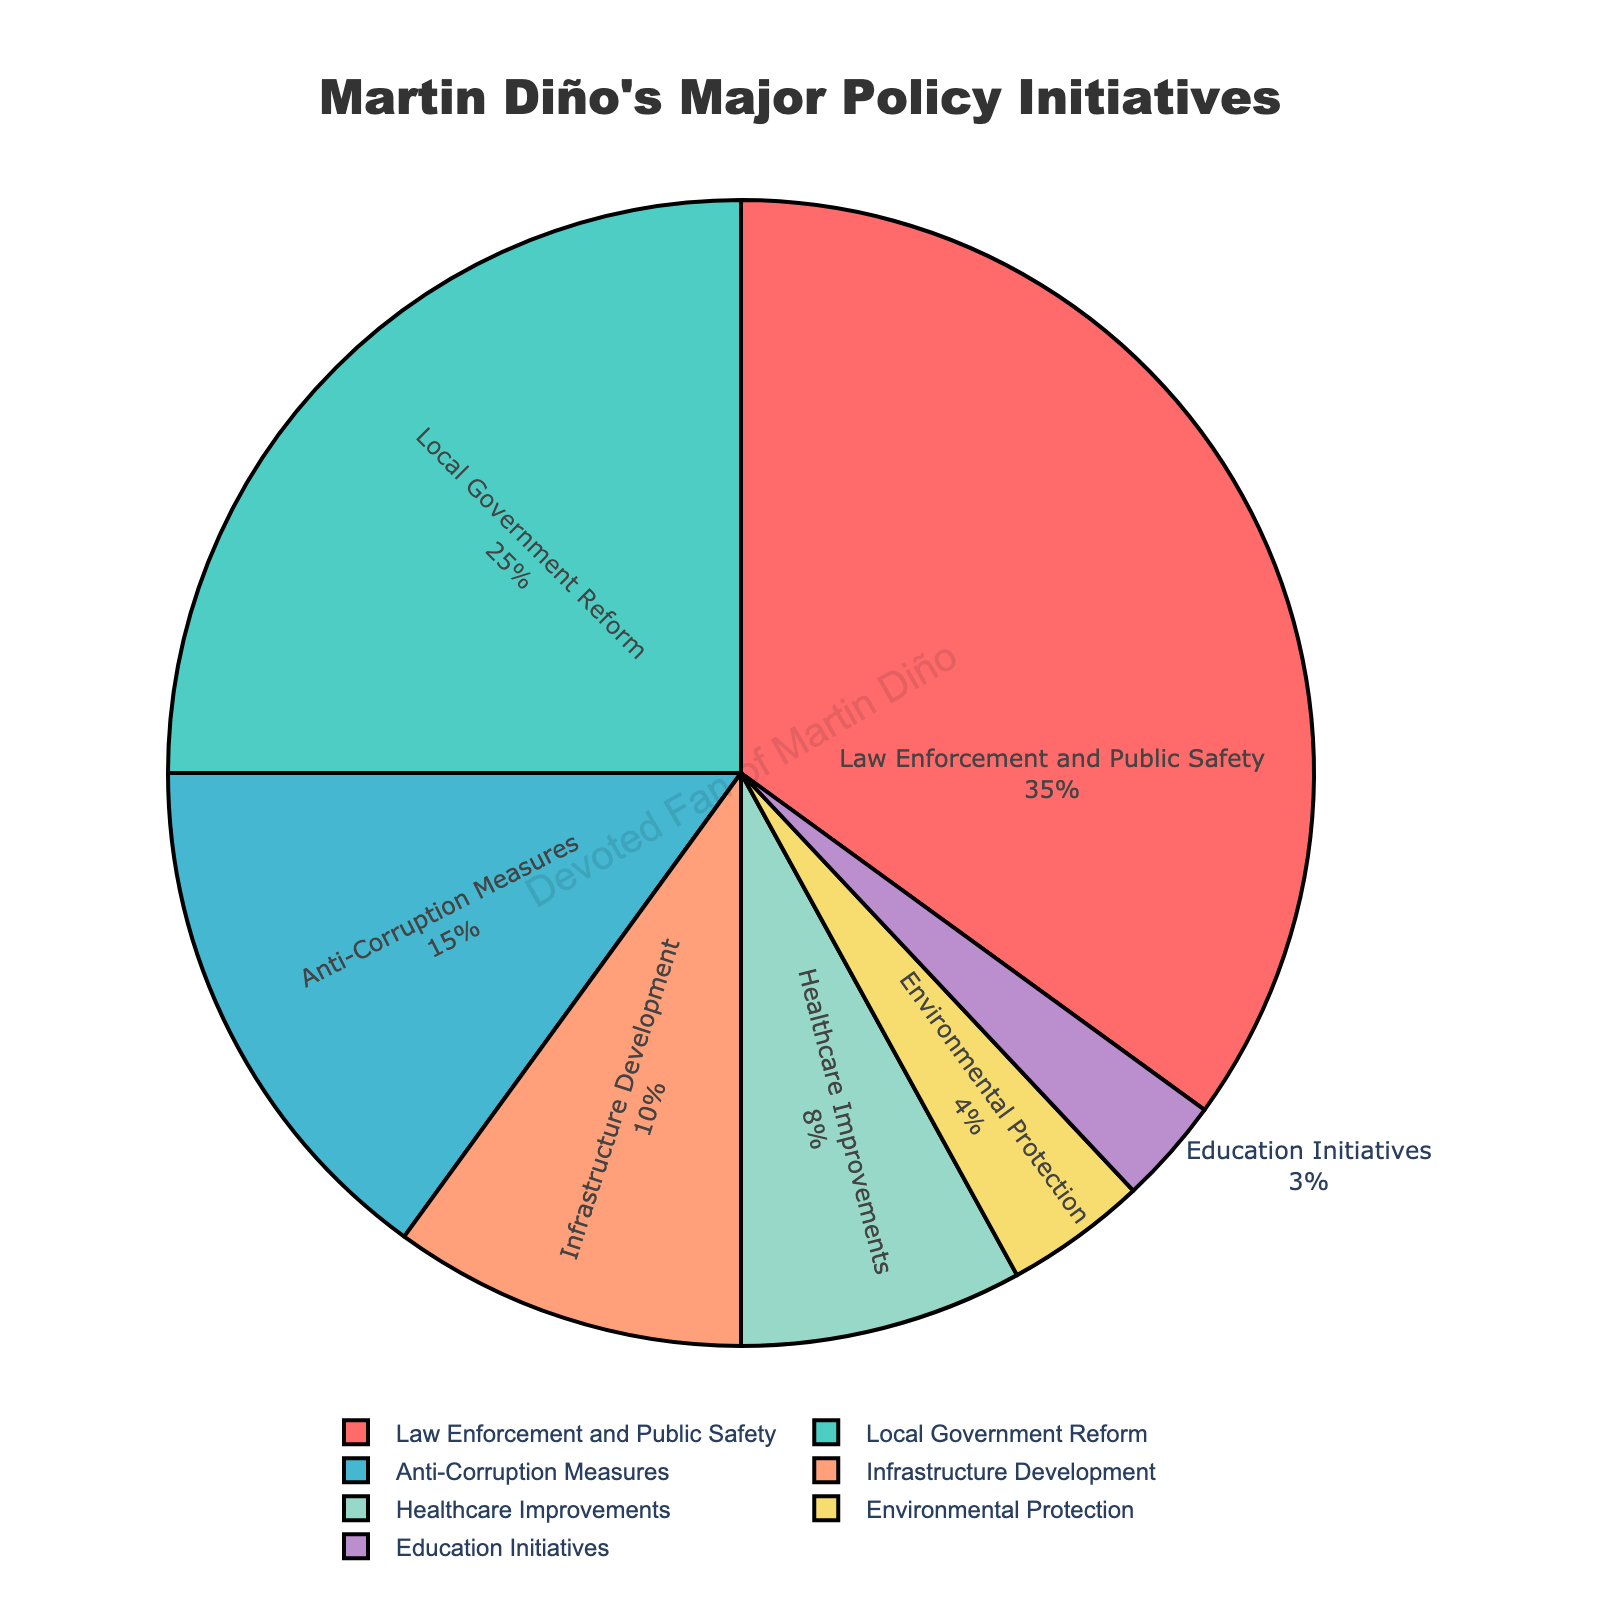What is the largest sector in Martin Diño's policy initiatives? The sector with the highest percentage represents the largest sector in Martin Diño's policy initiatives. According to the pie chart, "Law Enforcement and Public Safety" has the highest percentage at 35%.
Answer: Law Enforcement and Public Safety Which sector has the smallest percentage in Martin Diño's policy initiatives? The sector with the lowest percentage represents the smallest sector in Martin Diño's policy initiatives. According to the pie chart, "Education Initiatives" has the lowest percentage at 3%.
Answer: Education Initiatives How much more percentage is allocated to Law Enforcement and Public Safety compared to Anti-Corruption Measures? To find this, subtract the percentage of Anti-Corruption Measures (15%) from the percentage of Law Enforcement and Public Safety (35%). The difference is 35% - 15% = 20%.
Answer: 20% What is the combined percentage of Local Government Reform and Healthcare Improvements? To find the combined percentage, add the percentages of both sectors: Local Government Reform (25%) and Healthcare Improvements (8%). The sum is 25% + 8% = 33%.
Answer: 33% Is the percentage allocated to Infrastructure Development higher than Healthcare Improvements? By how much? Compare the percentages of Infrastructure Development (10%) and Healthcare Improvements (8%). Infrastructure Development has a larger percentage, and the difference is 10% - 8% = 2%.
Answer: Yes, by 2% What is the combined percentage of sectors that have a percentage less than or equal to 10%? Add the percentages of Infrastructure Development (10%), Healthcare Improvements (8%), Environmental Protection (4%), and Education Initiatives (3%). The combined percentage is 10% + 8% + 4% + 3% = 25%.
Answer: 25% How does the percentage of Local Government Reform compare to Environmental Protection and Education Initiatives combined? First, sum the percentages of Environmental Protection (4%) and Education Initiatives (3%), which is 4% + 3% = 7%. The percentage of Local Government Reform is 25%, which is 25% - 7% = 18% higher than the combined value of the two other sectors.
Answer: 18% higher Which sectors have more than twice the percentage of Education Initiatives? "Education Initiatives" has 3%. Any sector with more than 6% (twice of 3%) falls into this category. These sectors are: Law Enforcement and Public Safety (35%), Local Government Reform (25%), Anti-Corruption Measures (15%), Infrastructure Development (10%), and Healthcare Improvements (8%).
Answer: Law Enforcement and Public Safety, Local Government Reform, Anti-Corruption Measures, Infrastructure Development, Healthcare Improvements 